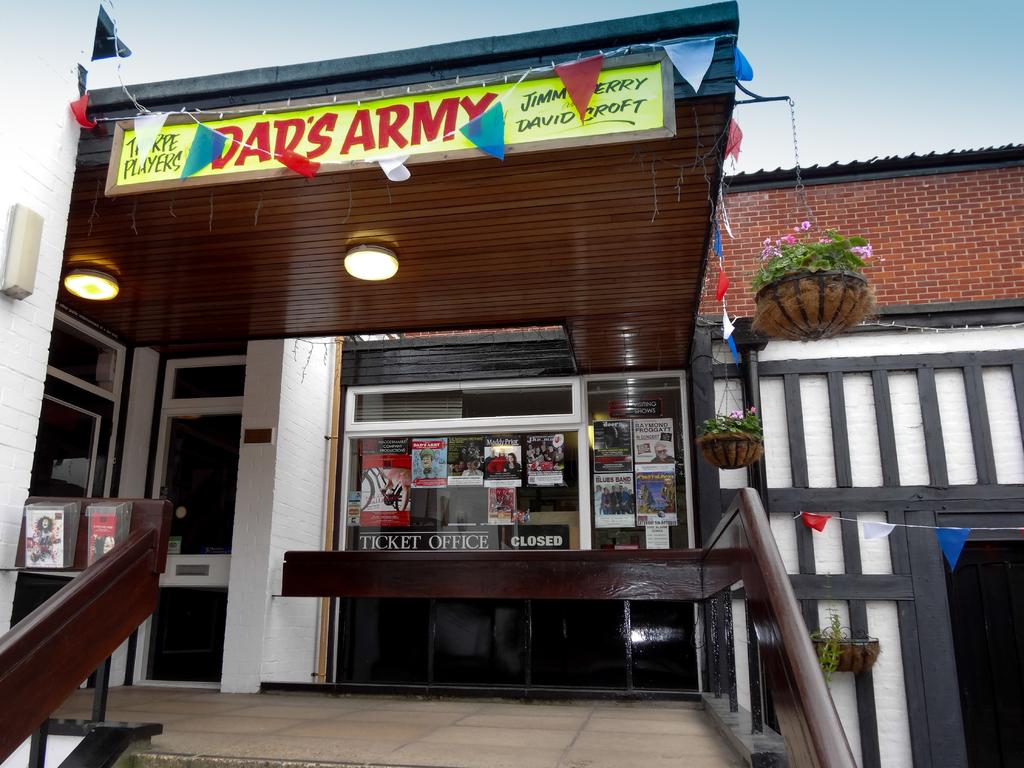Provide a one-sentence caption for the provided image. A sign for a show called "Dad's Army" sits atop the entrance to a theater box office. 